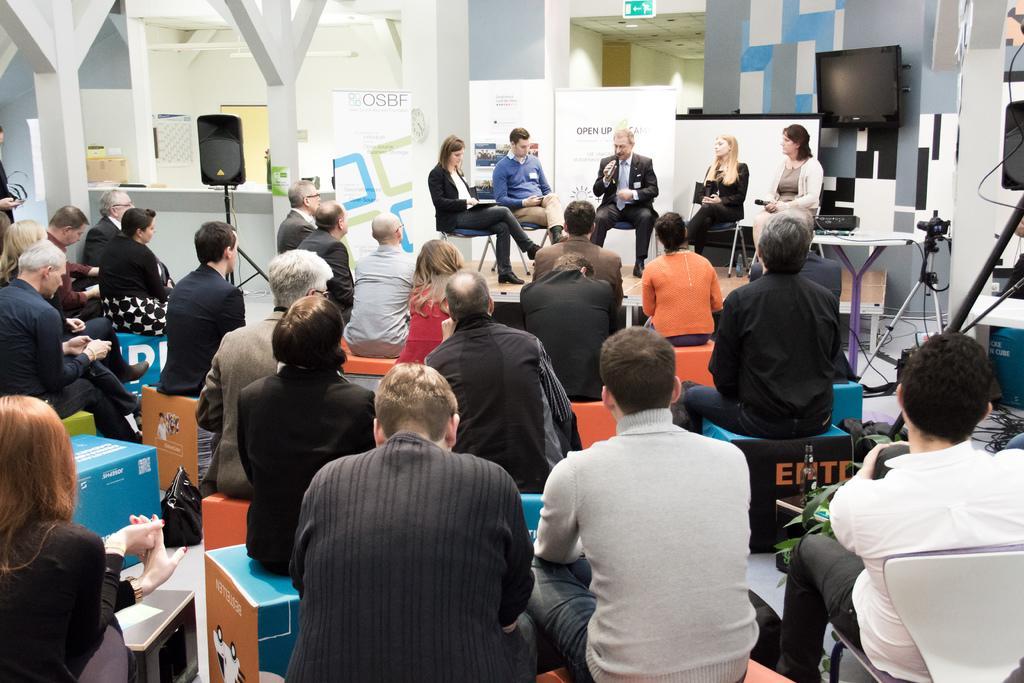Can you describe this image briefly? In this picture there are five persons near to the banner and television screen. At the bottom we can see the audience were sitting on the cotton boxes type chair. On the right there is a camera near to the wall. On the left there is a speaker. At the top there is a sign board. 